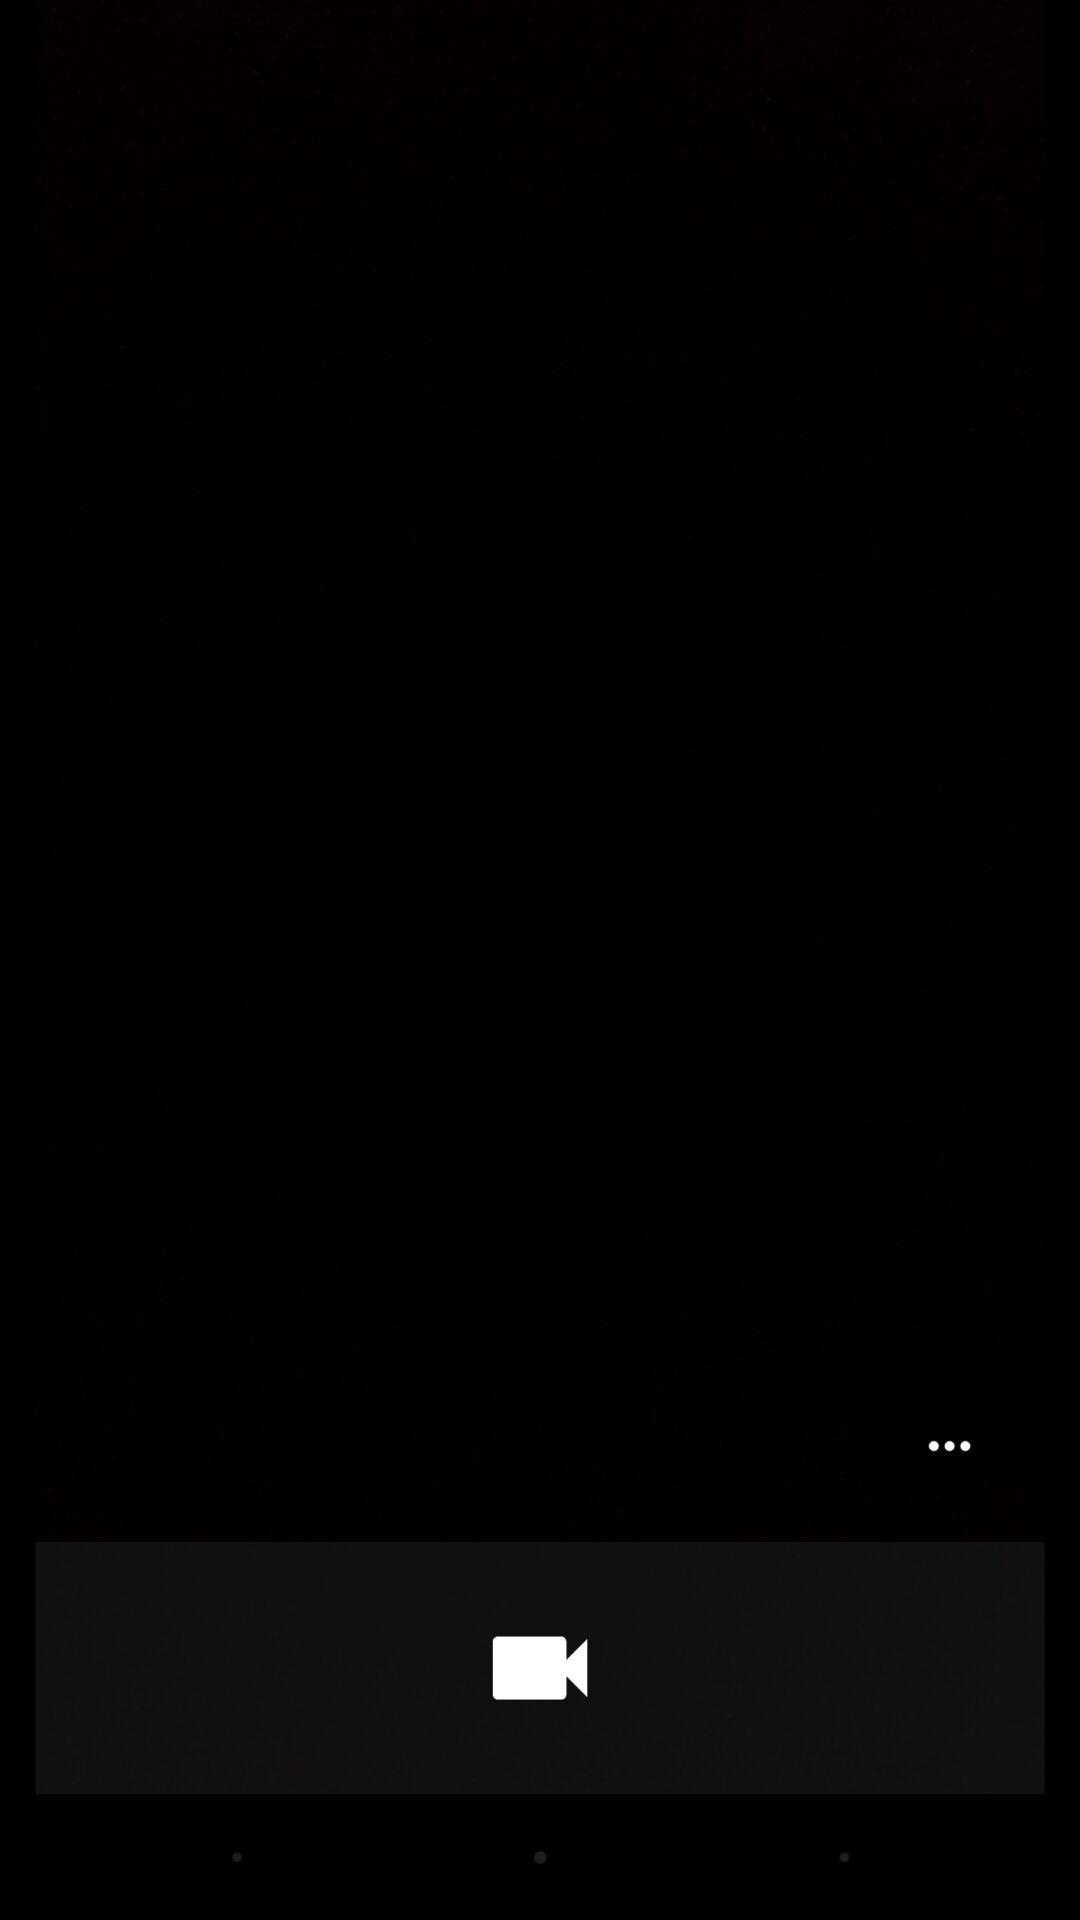Give me a narrative description of this picture. Screen displaying a video icon. 